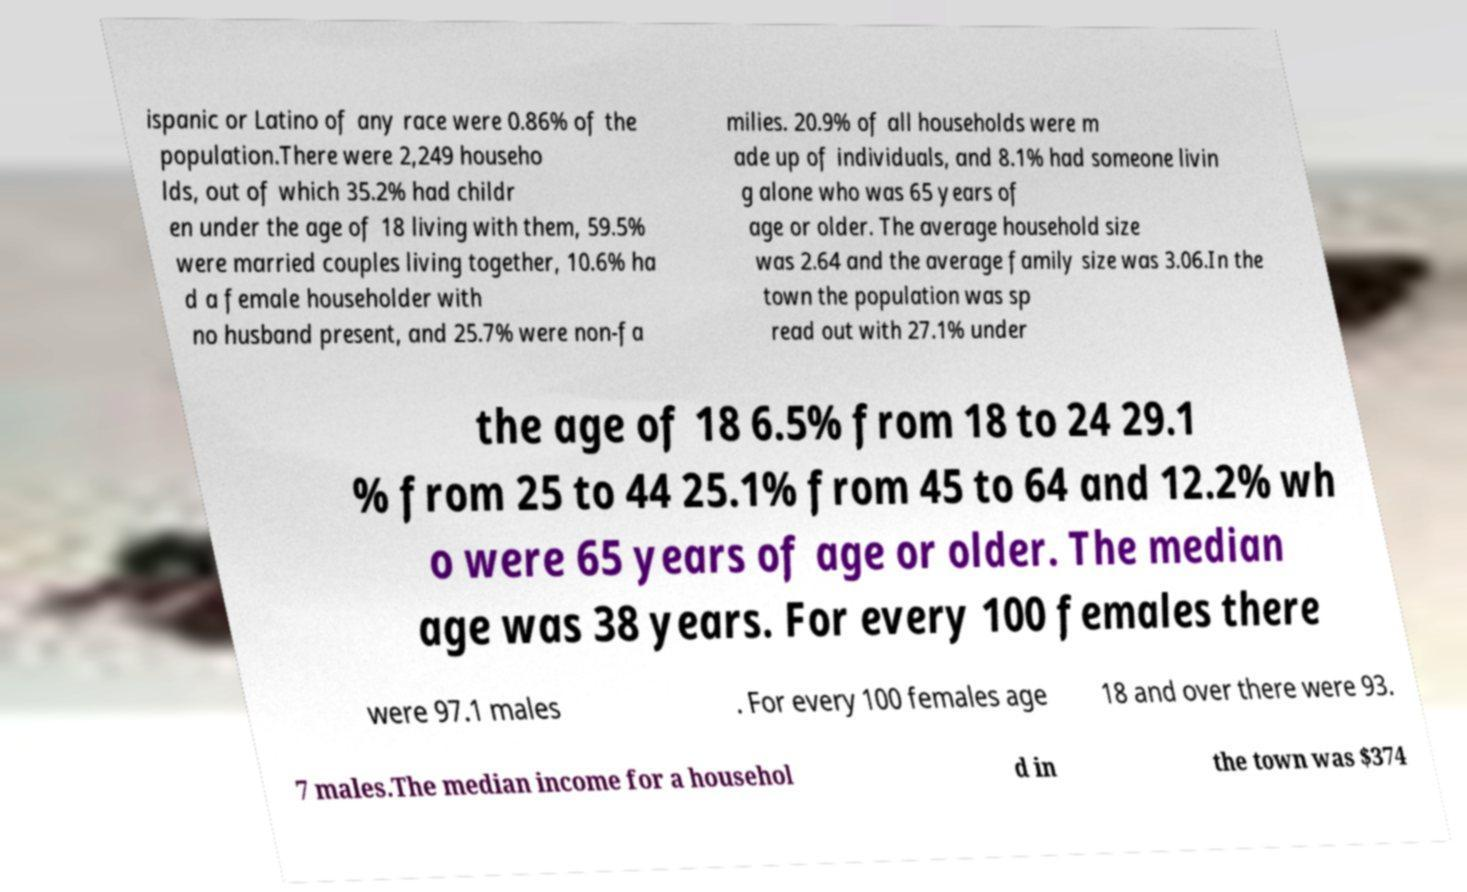Can you accurately transcribe the text from the provided image for me? ispanic or Latino of any race were 0.86% of the population.There were 2,249 househo lds, out of which 35.2% had childr en under the age of 18 living with them, 59.5% were married couples living together, 10.6% ha d a female householder with no husband present, and 25.7% were non-fa milies. 20.9% of all households were m ade up of individuals, and 8.1% had someone livin g alone who was 65 years of age or older. The average household size was 2.64 and the average family size was 3.06.In the town the population was sp read out with 27.1% under the age of 18 6.5% from 18 to 24 29.1 % from 25 to 44 25.1% from 45 to 64 and 12.2% wh o were 65 years of age or older. The median age was 38 years. For every 100 females there were 97.1 males . For every 100 females age 18 and over there were 93. 7 males.The median income for a househol d in the town was $374 